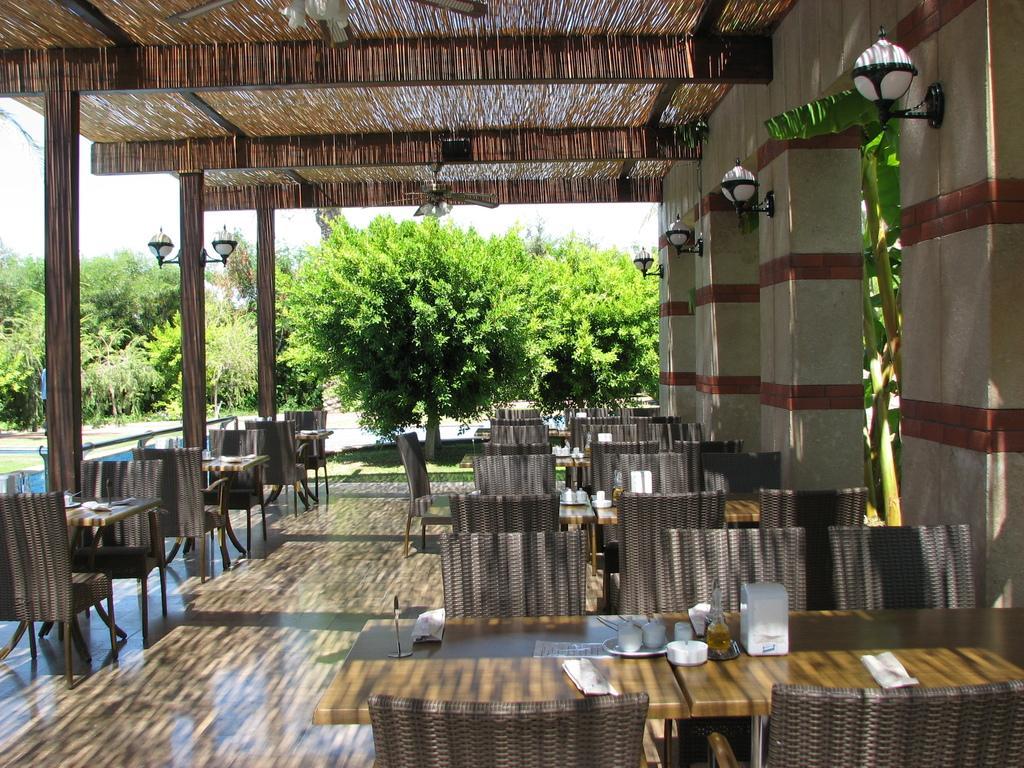Describe this image in one or two sentences. In this image we can see chairs, tables, metal lights, pillars, fans, trees and we can also see some objects placed on the table. 